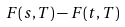<formula> <loc_0><loc_0><loc_500><loc_500>F ( s , T ) - F ( t , T )</formula> 